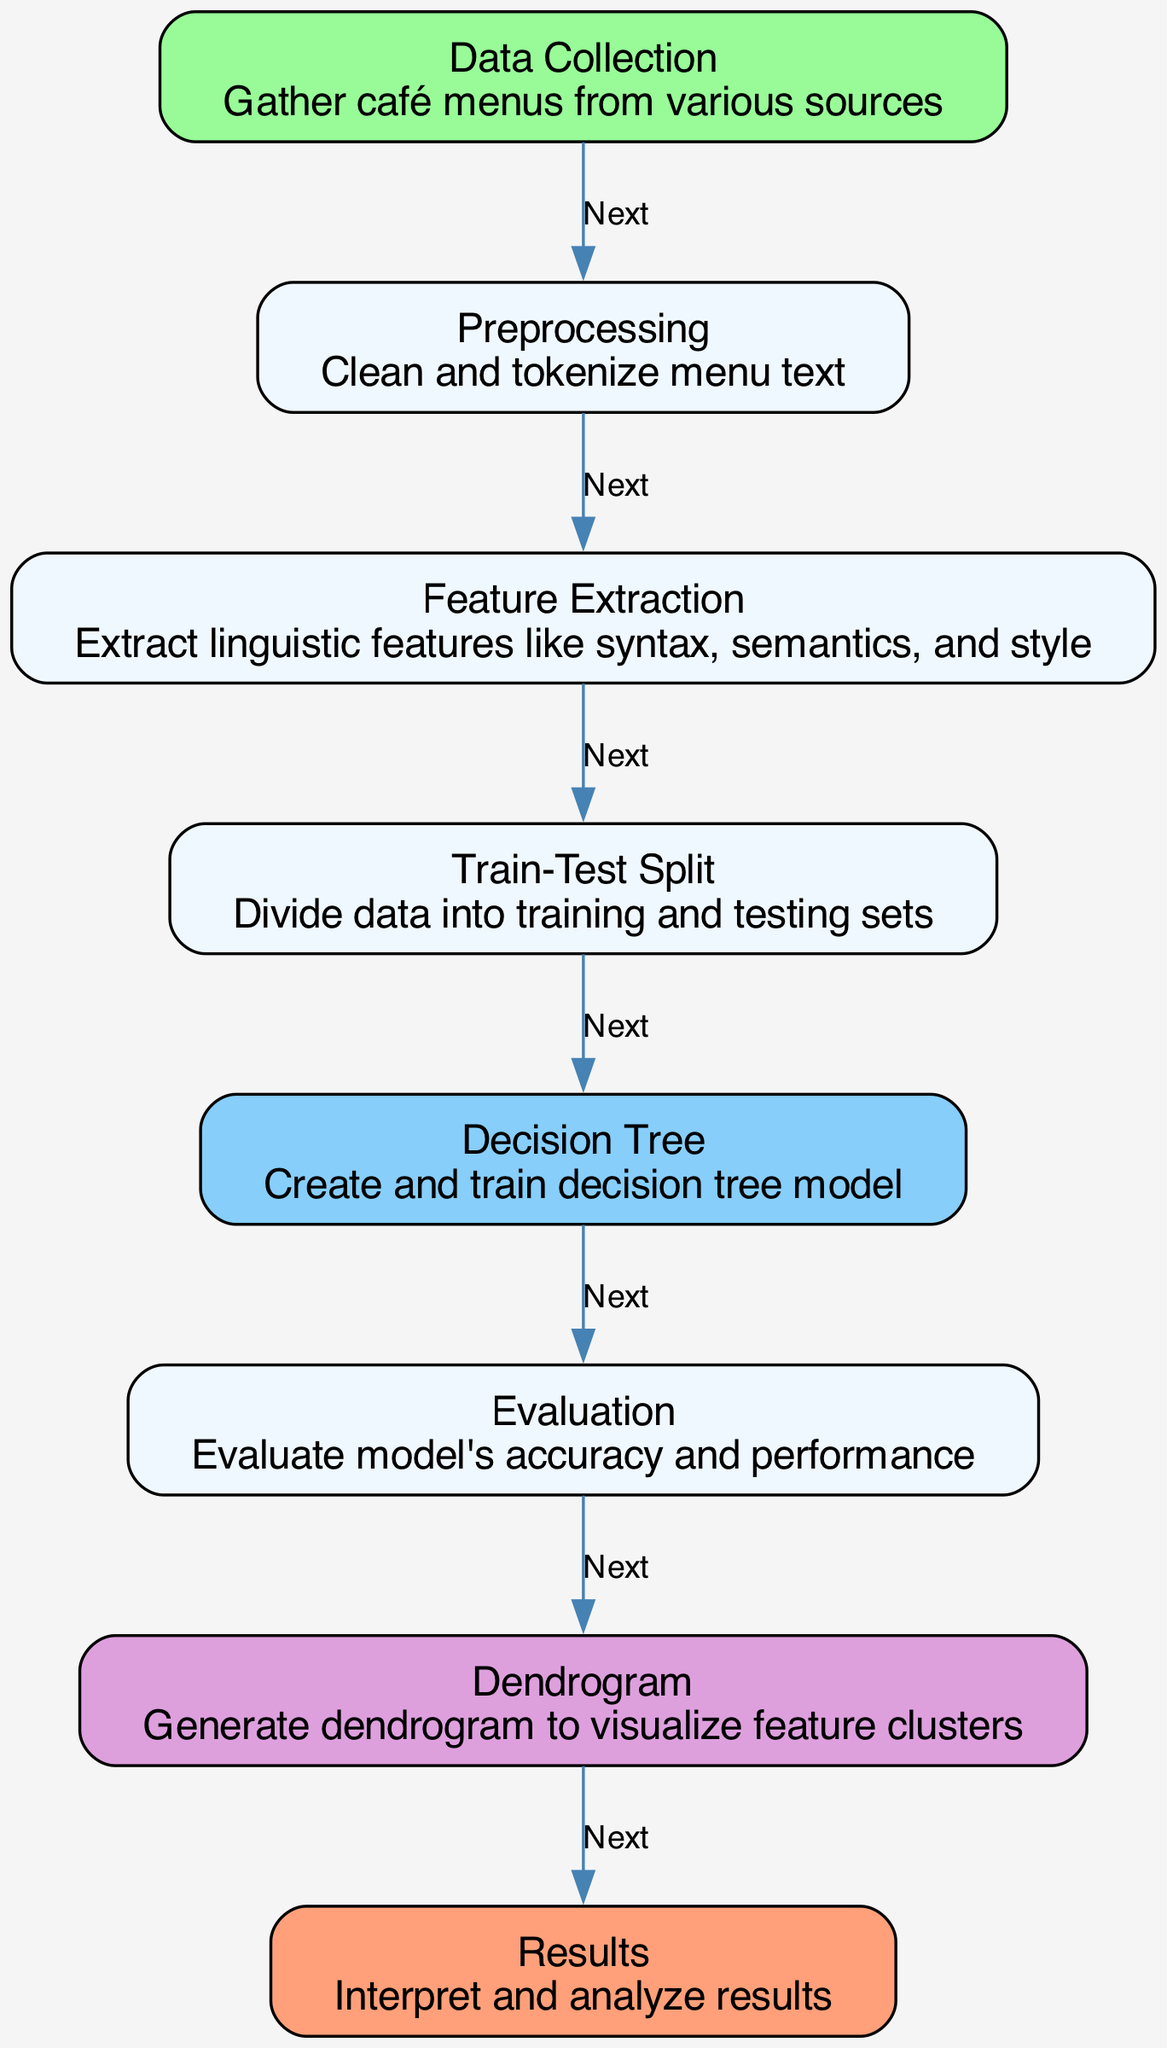What is the first step in the process? The first step is 'Data Collection', which involves gathering café menus from various sources.
Answer: Data Collection How many nodes are present in the diagram? By counting each distinct node listed in the data, there are eight nodes in total.
Answer: 8 What is the last step of the diagram? The last step is 'Results', which involves interpreting and analyzing results.
Answer: Results What follows 'Feature Extraction'? After 'Feature Extraction', the next step is 'Train-Test Split', where the data is divided into training and testing sets.
Answer: Train-Test Split How many edges connect 'Evaluation' to other nodes? There is one edge leaving 'Evaluation', which connects it to 'Dendrogram'.
Answer: 1 What does the 'Dendrogram' represent? The 'Dendrogram' is used to visualize feature clusters, helping to understand the relationships among linguistic features extracted from café menus.
Answer: Visualize feature clusters Describe the relationship between 'Preprocessing' and 'Feature Extraction'. 'Preprocessing' directly leads to 'Feature Extraction', indicating that the text must first be cleaned and tokenized before linguistic features can be extracted.
Answer: Next Which node introduces the decision tree model? The 'Decision Tree' node is where the decision tree model is created and trained after the training set is prepared.
Answer: Decision Tree What is the purpose of the 'Evaluation' node? The purpose of the 'Evaluation' node is to assess the model's accuracy and performance after it has been trained on the data.
Answer: Evaluate model's accuracy and performance 